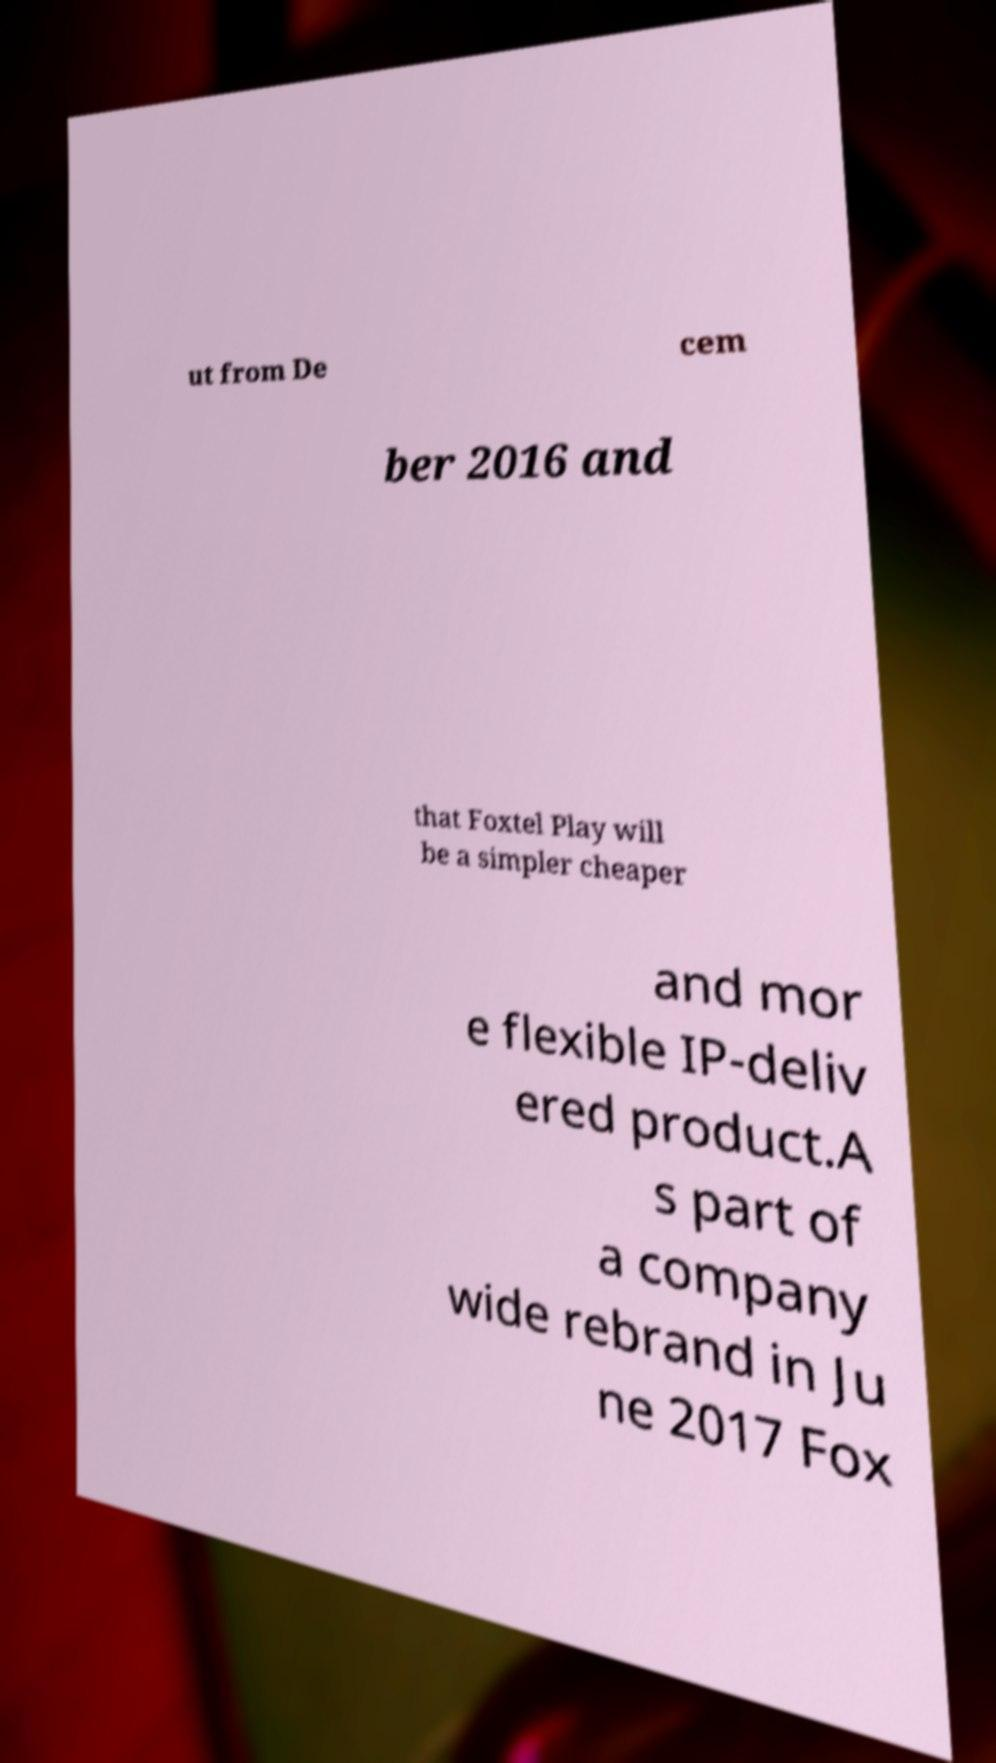Can you read and provide the text displayed in the image?This photo seems to have some interesting text. Can you extract and type it out for me? ut from De cem ber 2016 and that Foxtel Play will be a simpler cheaper and mor e flexible IP-deliv ered product.A s part of a company wide rebrand in Ju ne 2017 Fox 